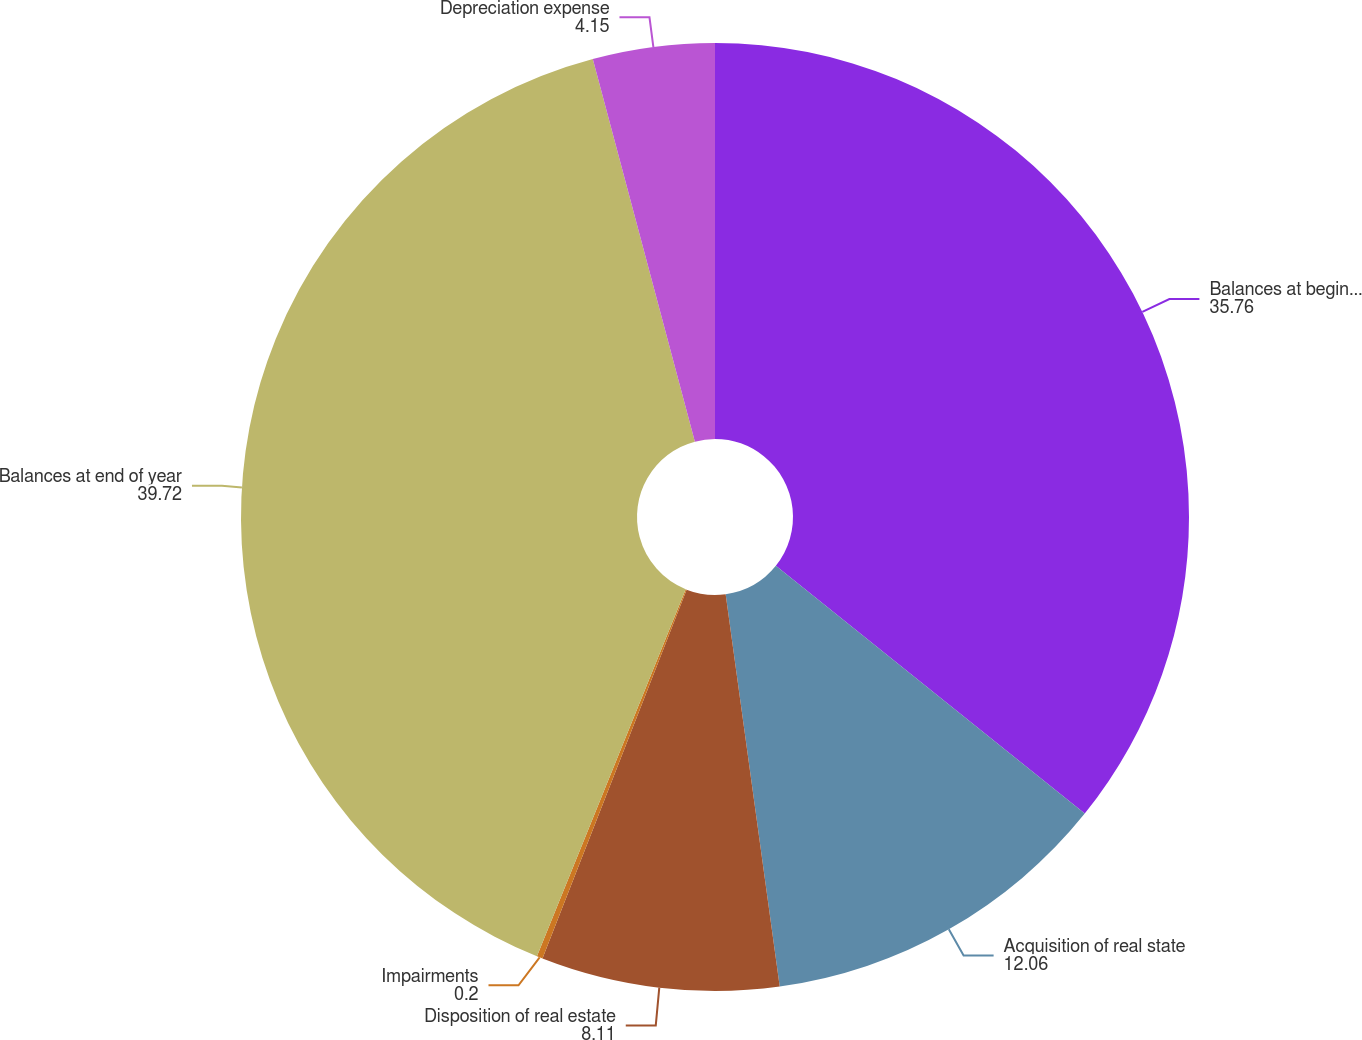<chart> <loc_0><loc_0><loc_500><loc_500><pie_chart><fcel>Balances at beginning of year<fcel>Acquisition of real state<fcel>Disposition of real estate<fcel>Impairments<fcel>Balances at end of year<fcel>Depreciation expense<nl><fcel>35.76%<fcel>12.06%<fcel>8.11%<fcel>0.2%<fcel>39.72%<fcel>4.15%<nl></chart> 